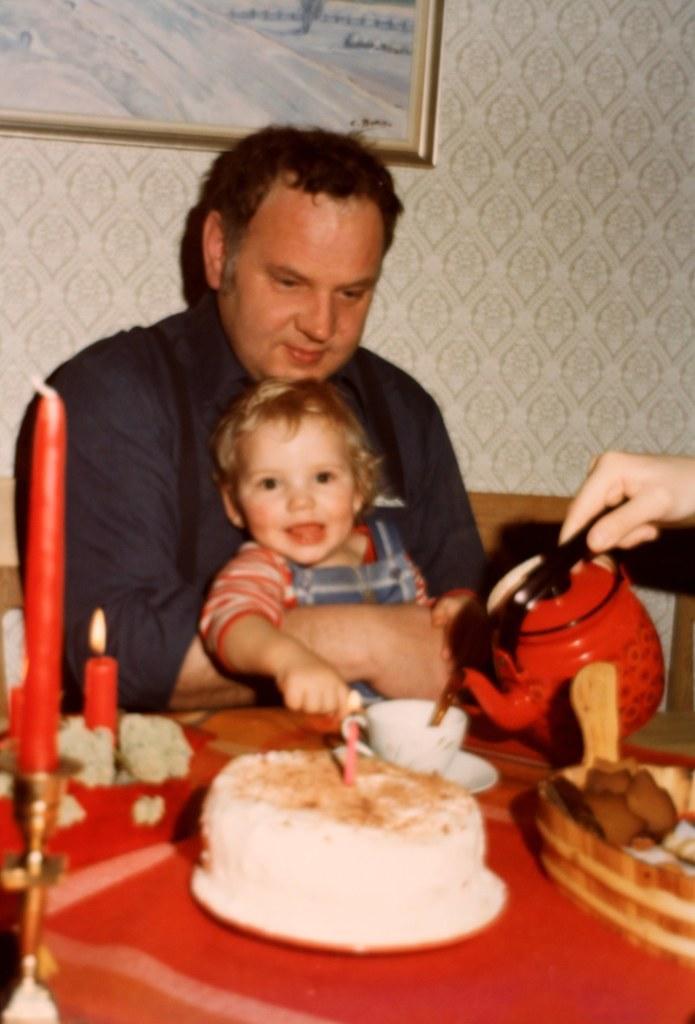In one or two sentences, can you explain what this image depicts? In the picture I can see a person wearing the black color shirt is carrying a child and sitting in front of the table. Here I can see a cake, cup with saucer, some food items, candles to the stand are placed on the stand. On the right side of the I can see a person's hand holding red color kettle. In the background, I can see the photo frame on the wall. 